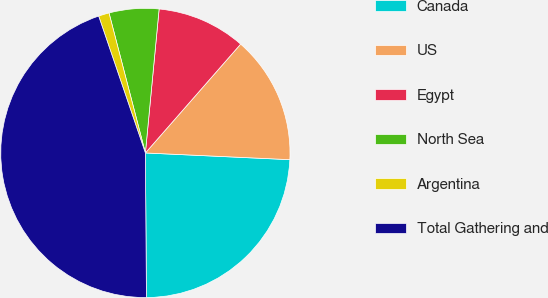<chart> <loc_0><loc_0><loc_500><loc_500><pie_chart><fcel>Canada<fcel>US<fcel>Egypt<fcel>North Sea<fcel>Argentina<fcel>Total Gathering and<nl><fcel>24.15%<fcel>14.3%<fcel>9.93%<fcel>5.56%<fcel>1.19%<fcel>44.89%<nl></chart> 